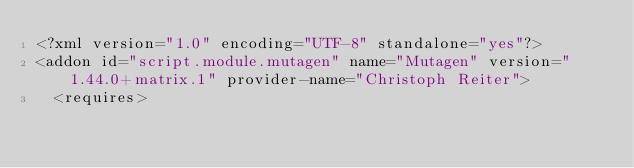<code> <loc_0><loc_0><loc_500><loc_500><_XML_><?xml version="1.0" encoding="UTF-8" standalone="yes"?>
<addon id="script.module.mutagen" name="Mutagen" version="1.44.0+matrix.1" provider-name="Christoph Reiter">
  <requires></code> 